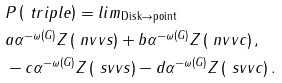<formula> <loc_0><loc_0><loc_500><loc_500>& P \left ( \ t r i p l e \right ) = l i m _ { \text {Disk} \rightarrow \text {point} } \\ & a \alpha ^ { - \omega ( G ) } Z \left ( \ n v v s \right ) + b \alpha ^ { - \omega ( G ) } Z \left ( \ n v v c \right ) , \\ & - c \alpha ^ { - \omega ( G ) } Z \left ( \ s v v s \right ) - d \alpha ^ { - \omega ( G ) } Z \left ( \ s v v c \right ) .</formula> 